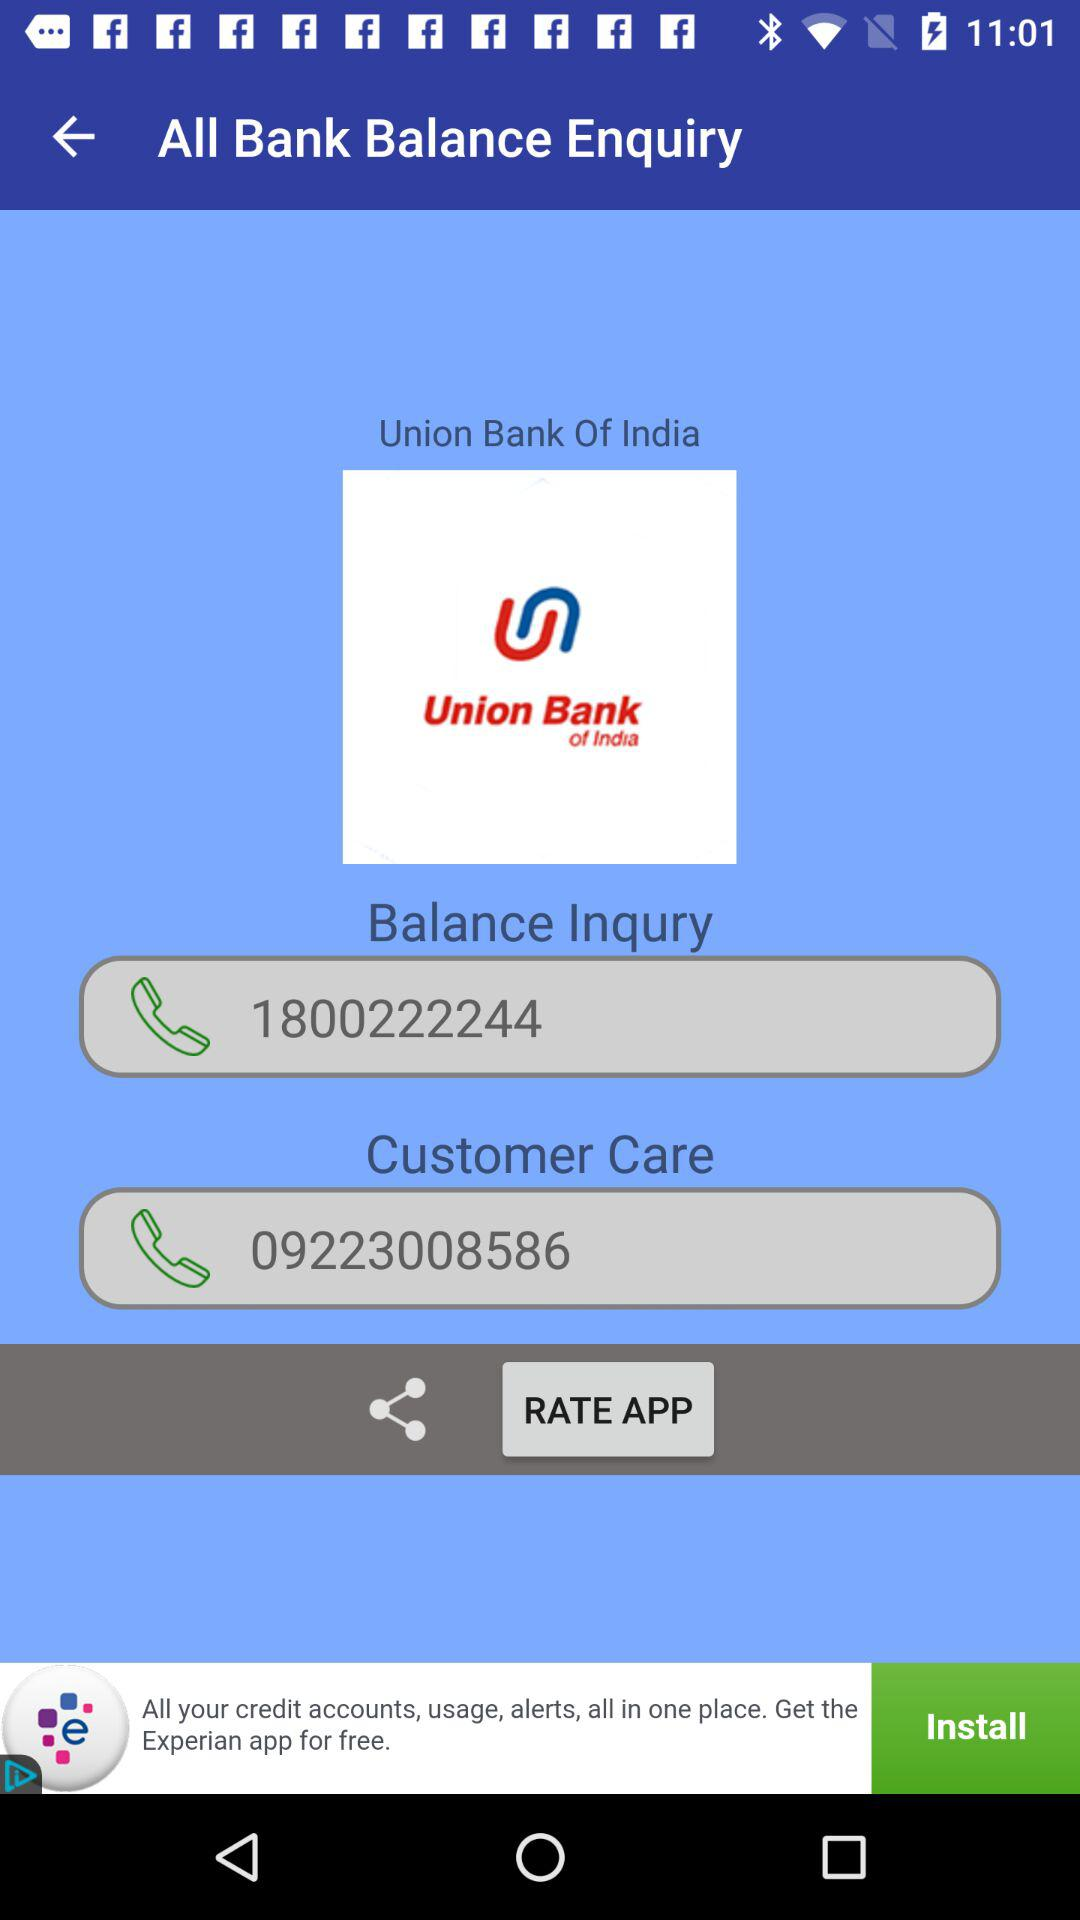What is the balance inquiry number? The balance inquiry number is 1800222244. 